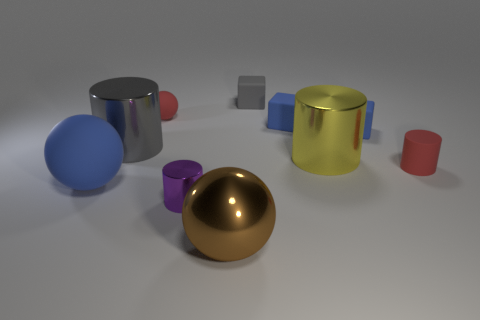Subtract all blue blocks. How many were subtracted if there are1blue blocks left? 1 Subtract all small red spheres. How many spheres are left? 2 Subtract all cyan cubes. How many red balls are left? 1 Subtract all gray blocks. How many blocks are left? 2 Subtract 0 blue cylinders. How many objects are left? 10 Subtract all spheres. How many objects are left? 7 Subtract 1 cylinders. How many cylinders are left? 3 Subtract all red cylinders. Subtract all green cubes. How many cylinders are left? 3 Subtract all red rubber cylinders. Subtract all blue rubber things. How many objects are left? 6 Add 3 small matte objects. How many small matte objects are left? 8 